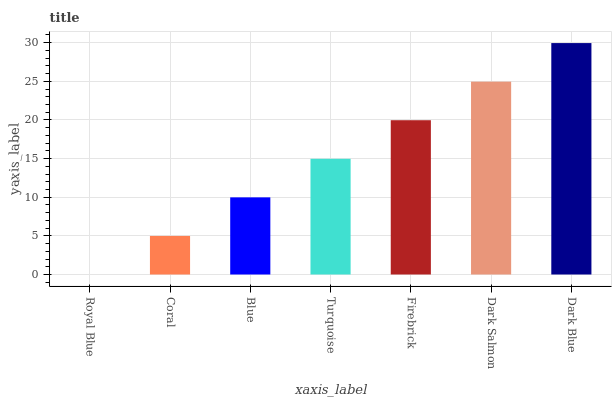Is Royal Blue the minimum?
Answer yes or no. Yes. Is Dark Blue the maximum?
Answer yes or no. Yes. Is Coral the minimum?
Answer yes or no. No. Is Coral the maximum?
Answer yes or no. No. Is Coral greater than Royal Blue?
Answer yes or no. Yes. Is Royal Blue less than Coral?
Answer yes or no. Yes. Is Royal Blue greater than Coral?
Answer yes or no. No. Is Coral less than Royal Blue?
Answer yes or no. No. Is Turquoise the high median?
Answer yes or no. Yes. Is Turquoise the low median?
Answer yes or no. Yes. Is Firebrick the high median?
Answer yes or no. No. Is Dark Salmon the low median?
Answer yes or no. No. 